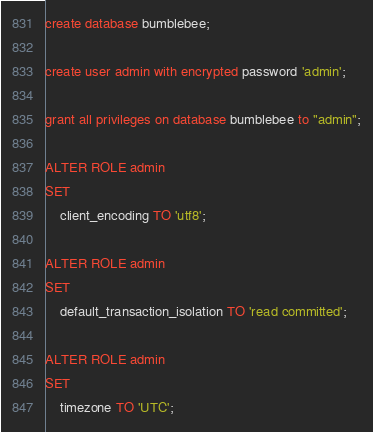Convert code to text. <code><loc_0><loc_0><loc_500><loc_500><_SQL_>create database bumblebee;

create user admin with encrypted password 'admin';

grant all privileges on database bumblebee to "admin";

ALTER ROLE admin
SET
    client_encoding TO 'utf8';

ALTER ROLE admin
SET
    default_transaction_isolation TO 'read committed';

ALTER ROLE admin
SET
    timezone TO 'UTC';
</code> 